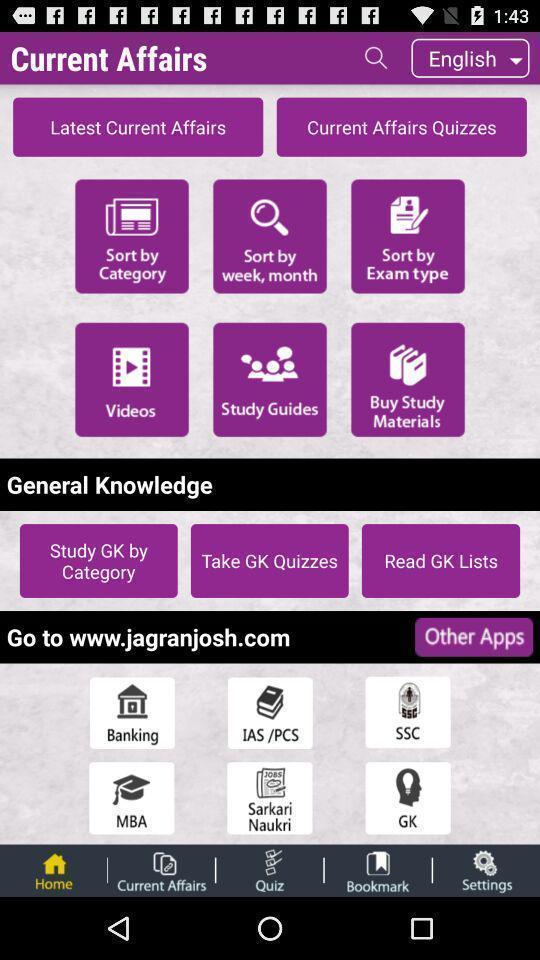Give me a narrative description of this picture. Screen showing home page. 